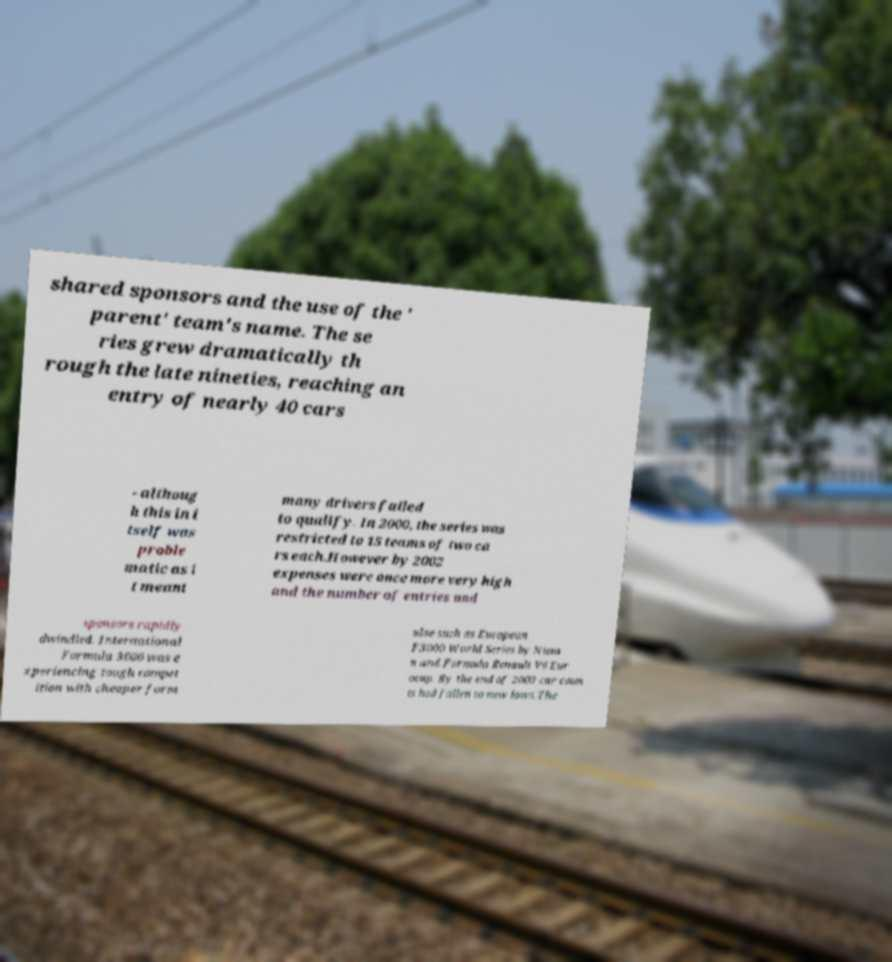Please identify and transcribe the text found in this image. shared sponsors and the use of the ' parent' team's name. The se ries grew dramatically th rough the late nineties, reaching an entry of nearly 40 cars - althoug h this in i tself was proble matic as i t meant many drivers failed to qualify. In 2000, the series was restricted to 15 teams of two ca rs each.However by 2002 expenses were once more very high and the number of entries and sponsors rapidly dwindled. International Formula 3000 was e xperiencing tough compet ition with cheaper form ulae such as European F3000 World Series by Nissa n and Formula Renault V6 Eur ocup. By the end of 2003 car coun ts had fallen to new lows.The 